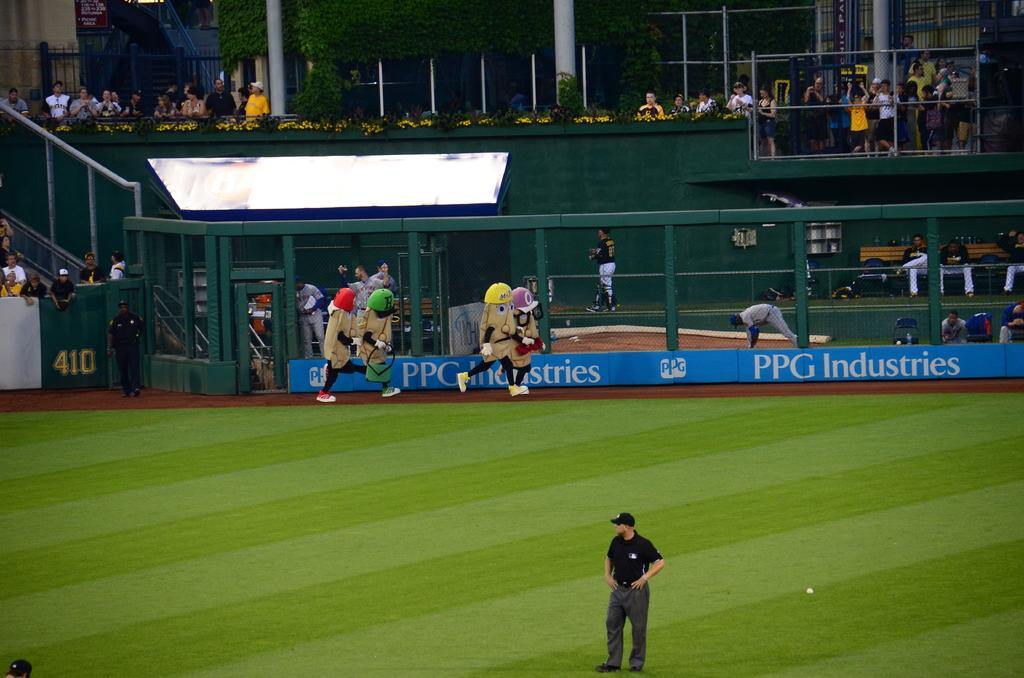<image>
Offer a succinct explanation of the picture presented. a sign with PPG industries on it in blue at a soccer game 